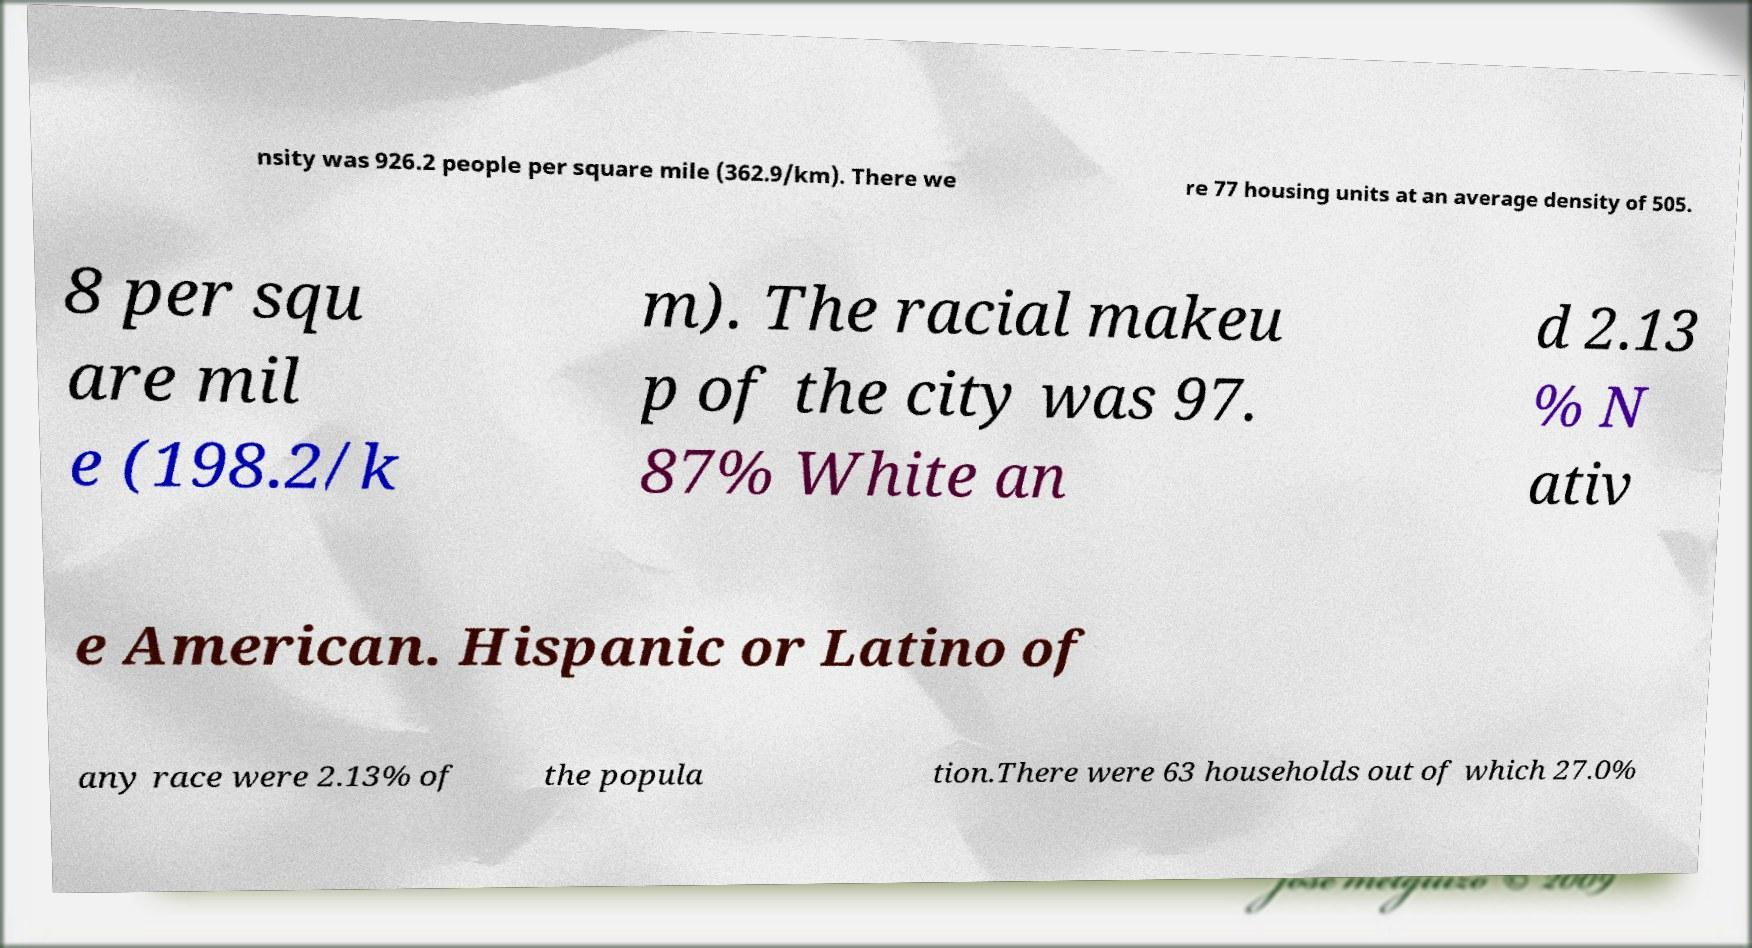Please identify and transcribe the text found in this image. nsity was 926.2 people per square mile (362.9/km). There we re 77 housing units at an average density of 505. 8 per squ are mil e (198.2/k m). The racial makeu p of the city was 97. 87% White an d 2.13 % N ativ e American. Hispanic or Latino of any race were 2.13% of the popula tion.There were 63 households out of which 27.0% 